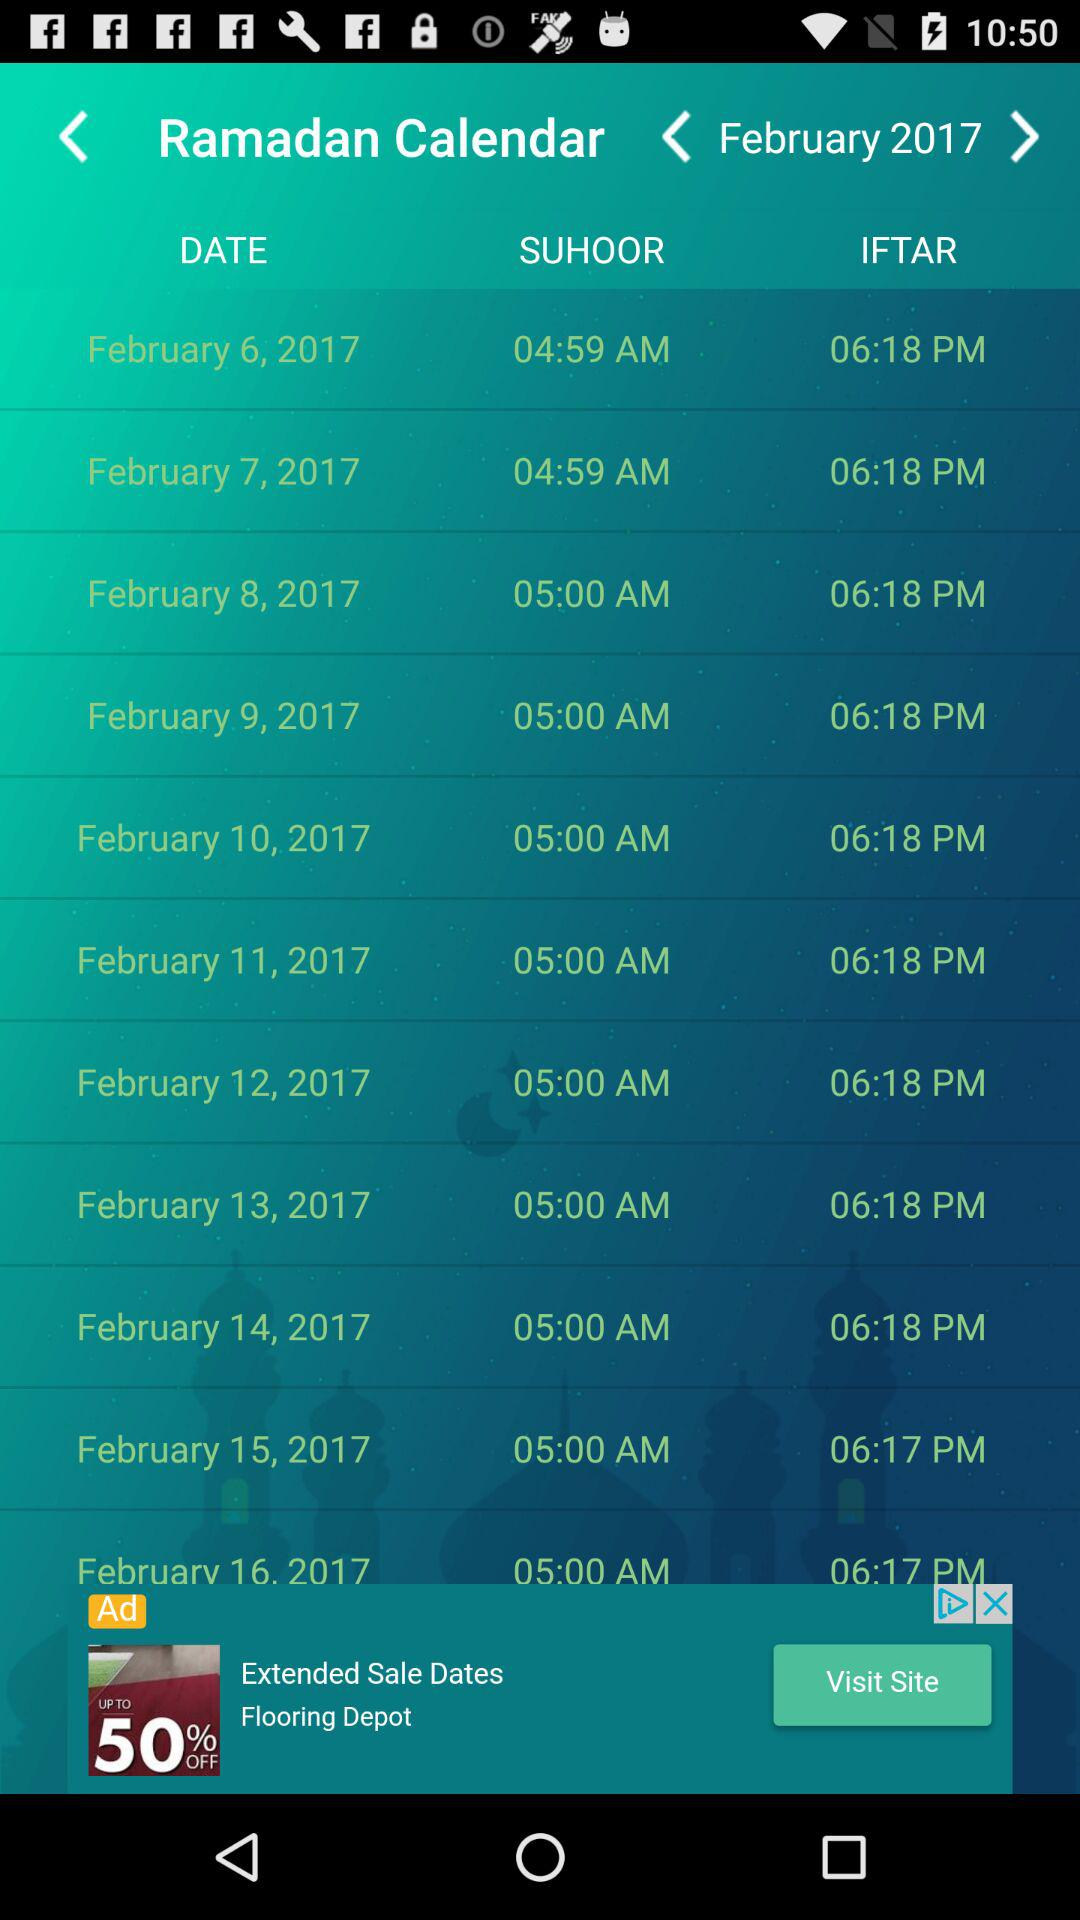What is the "IFTAR" time on the 12th of February? The "IFTAR" time on the 12th of February is 6:18 p.m. 